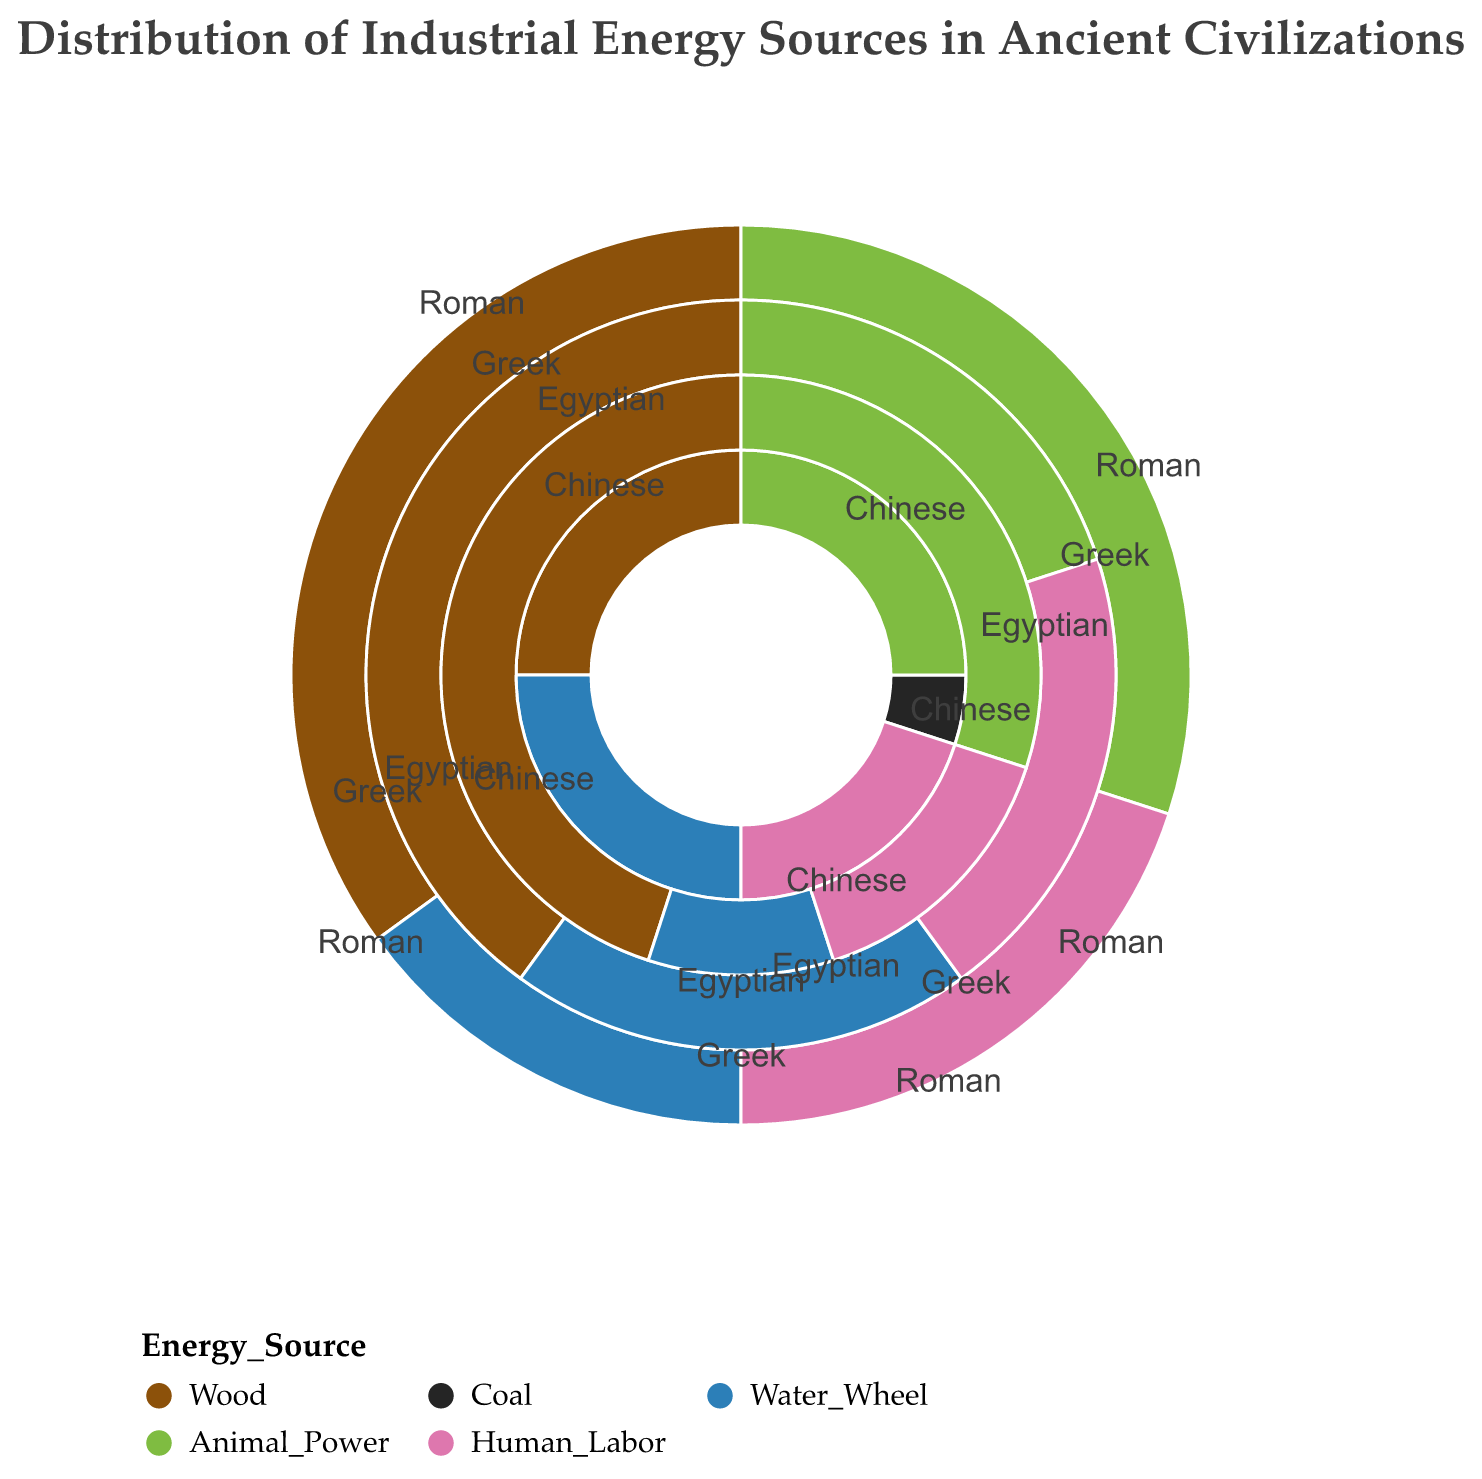What is the predominant energy source for the Greek civilization? The figure shows that for the Greek civilization, the largest section is labeled as "Wood" with a percentage of 40%, indicating it is the predominant energy source.
Answer: Wood Which civilization has the highest percentage of animal power usage? By examining the polar chart, the Roman and Egyptian civilizations both show 30% under the "Animal Power" category, thus they tie for the highest percentage.
Answer: Roman and Egyptian How does the percentage of human labor compare between the Chinese and Roman civilizations? According to the polar chart, both the Chinese and Roman civilizations allocate the same percentage to human labor, which is 20%.
Answer: Equal What is the total percentage of non-renewable energy sources (Coal) usage across all civilizations? Examining the chart, only the Chinese civilization uses coal with a 5% allocation. Summing up this single value results in a total of 5%.
Answer: 5% Among all civilizations, which one used the water wheel the most, and what is the percentage? Checking the water wheel segment in the chart, the Chinese civilization has the largest percentage at 25%.
Answer: Chinese, 25% Which civilization relies the most on wood as an energy source? By evaluating the wood sections for each civilization, the Egyptian civilization has the highest percentage at 45%.
Answer: Egyptian Combine the percentages of energy sources derived from animals (Animal Power) and human labor for the Greek civilization. What is the total? Summing up the values for animal power and human labor for the Greek civilization: 20% (Animal Power) + 20% (Human Labor) = 40%.
Answer: 40% How does the usage of water wheels in the Roman civilization compare to the same in the Egyptian civilization? The Roman civilization has 15% usage of water wheels, while the Egyptian civilization has 10%. Thus, the Romans use the water wheel more.
Answer: Roman uses more Which is more: the sum of wood and animal power in the Chinese civilization or just the wood in the Roman civilization? Calculating the sum for the Chinese civilization: 25% (Wood) + 25% (Animal Power) = 50%. The wood in the Roman civilization is 35%. Hence, the sum in the Chinese civilization is greater.
Answer: Chinese sum is greater 